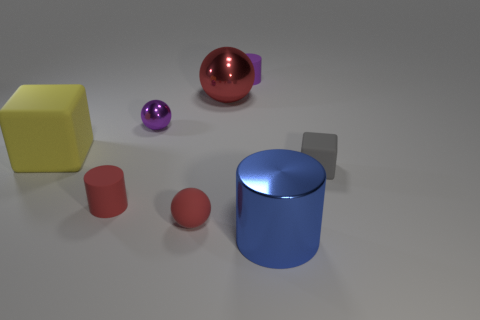Subtract all small rubber balls. How many balls are left? 2 Add 1 blue metal objects. How many objects exist? 9 Subtract all gray cubes. How many cubes are left? 1 Subtract all cyan blocks. How many red spheres are left? 2 Subtract 1 cylinders. How many cylinders are left? 2 Subtract all big red metal balls. Subtract all tiny objects. How many objects are left? 2 Add 4 small purple matte things. How many small purple matte things are left? 5 Add 2 small blocks. How many small blocks exist? 3 Subtract 0 brown spheres. How many objects are left? 8 Subtract all cylinders. How many objects are left? 5 